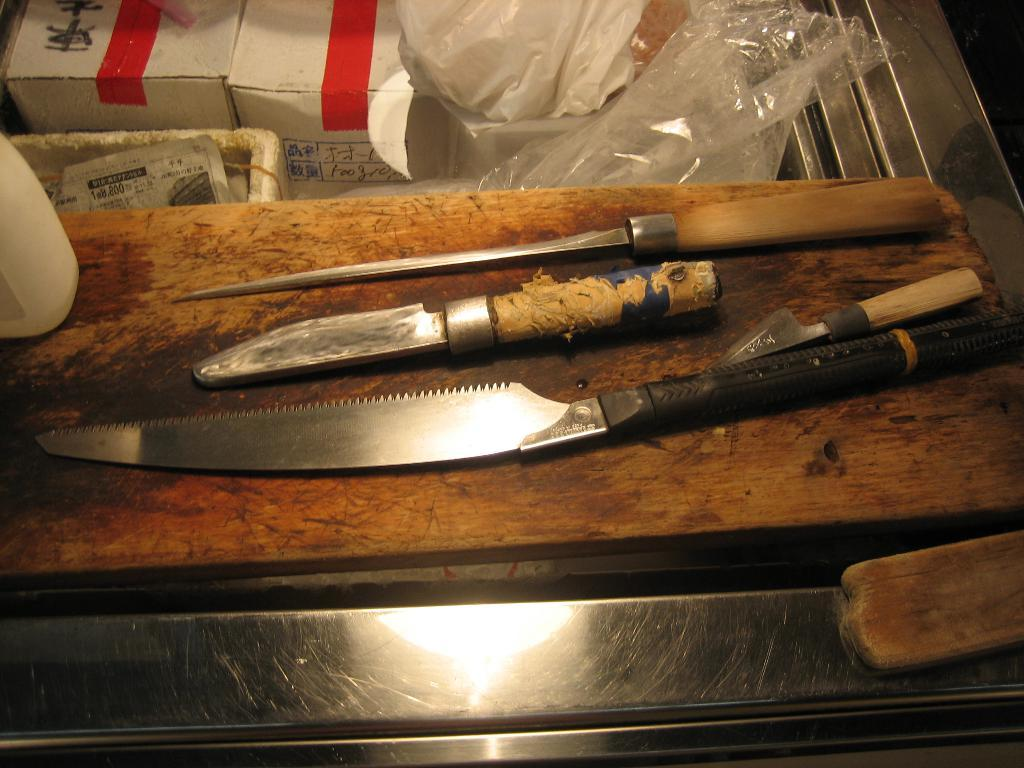What type of sharp objects are present in the image? There are knives in the image. What type of protective covering is present in the image? There are plastic covers in the image. What type of storage containers are present in the image? There are boxes in the image. What type of liquid container is present in the image? There is a bottle in the image. How many toes are visible in the image? There are no toes visible in the image. What type of toy is present in the image? There is no toy present in the image. 